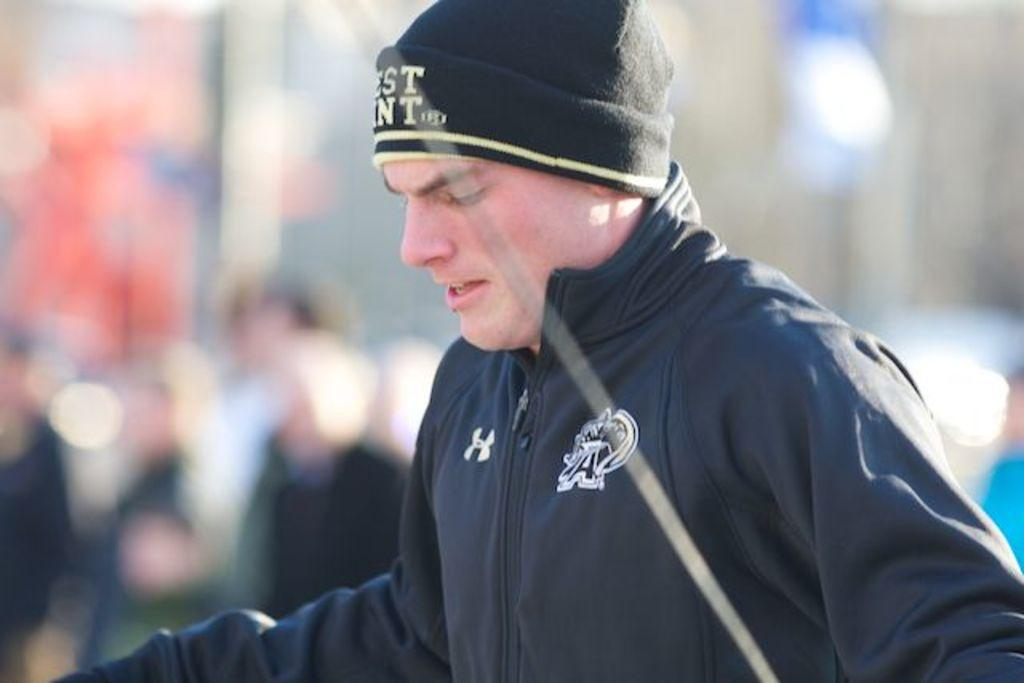Who is present in the image? There is a man in the image. What is the man wearing on his upper body? The man is wearing a black jacket. What type of headwear is the man wearing? The man is wearing a cap. Can you describe the background of the image? The background of the image is blurry. What type of icicle can be seen hanging from the man's cap in the image? There is no icicle present in the image, nor is it hanging from the man's cap. 